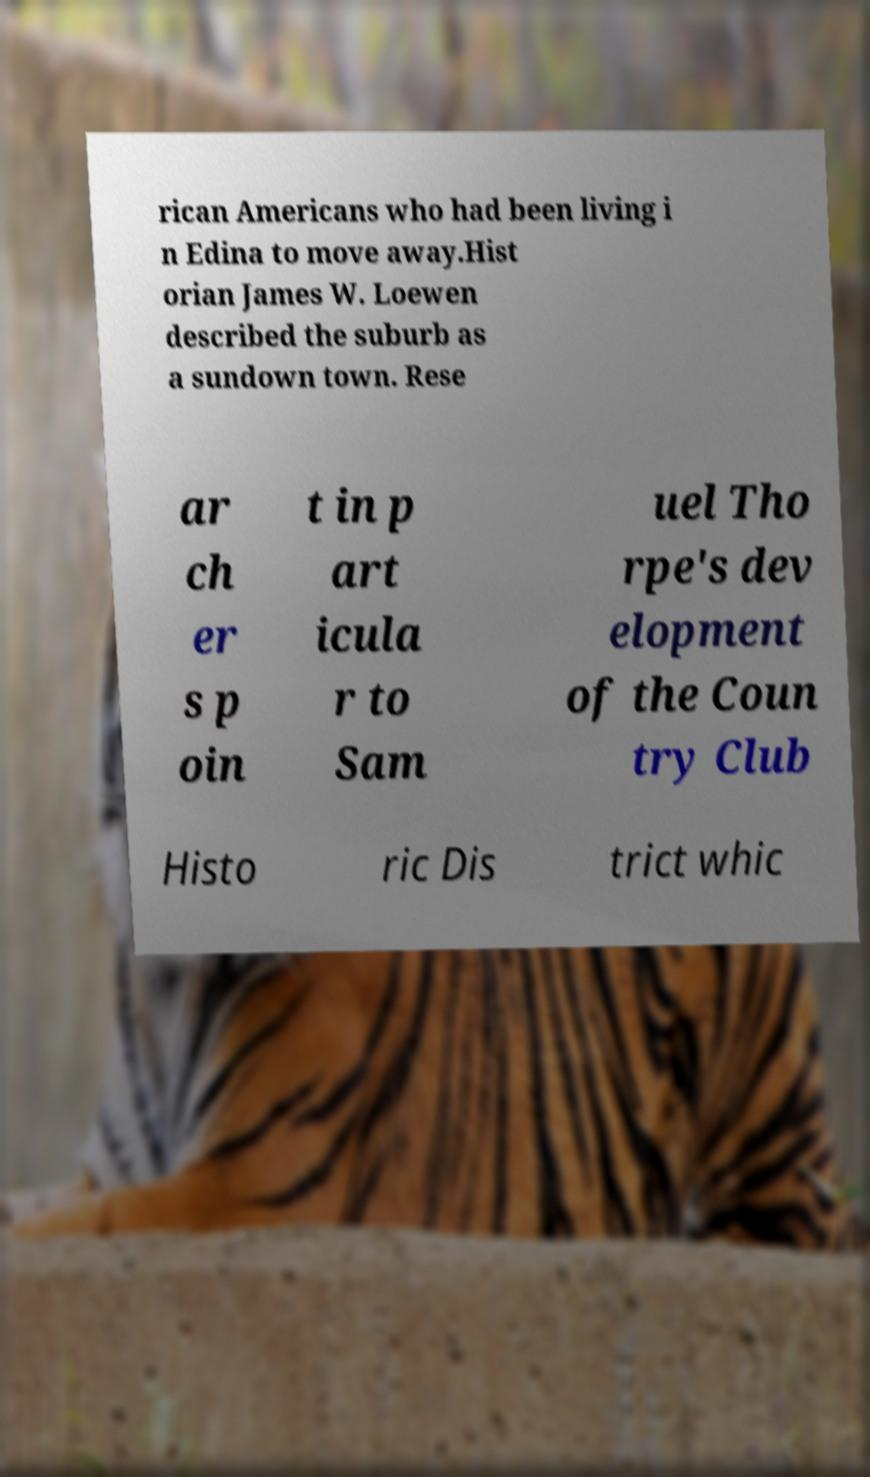Please identify and transcribe the text found in this image. rican Americans who had been living i n Edina to move away.Hist orian James W. Loewen described the suburb as a sundown town. Rese ar ch er s p oin t in p art icula r to Sam uel Tho rpe's dev elopment of the Coun try Club Histo ric Dis trict whic 